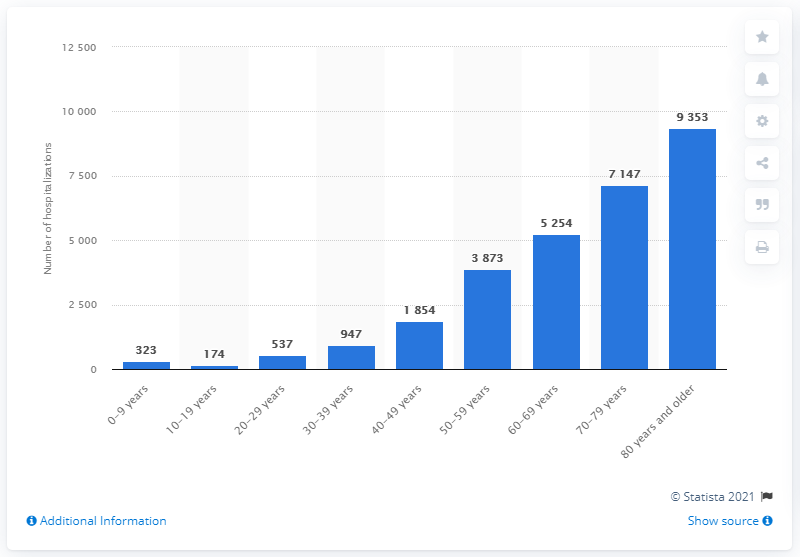Specify some key components in this picture. The age group of patients most frequently hospitalized due to COVID-19 infection are those aged 80 years and older. 